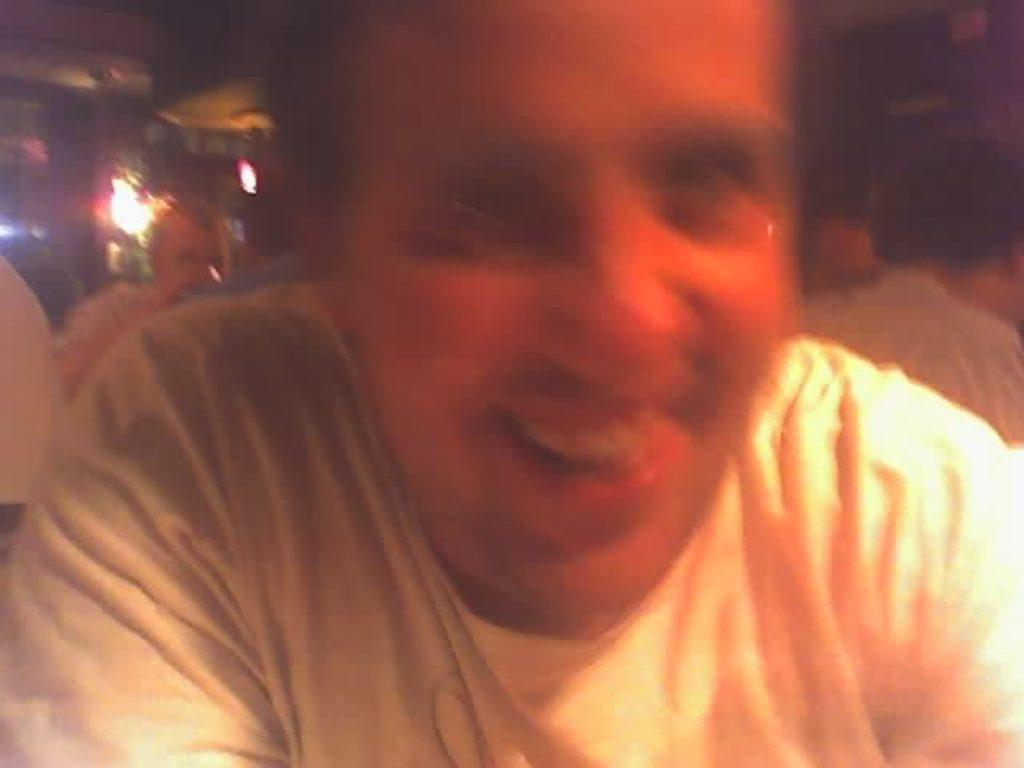What is the main subject in the foreground of the image? There is a person in the foreground of the image. What is the person doing in the image? The person is smiling. What can be seen in the background of the image? There are lights, other persons, tents, and other objects in the background of the image. What type of lamp is hanging from the mine in the image? There is no lamp or mine present in the image. 